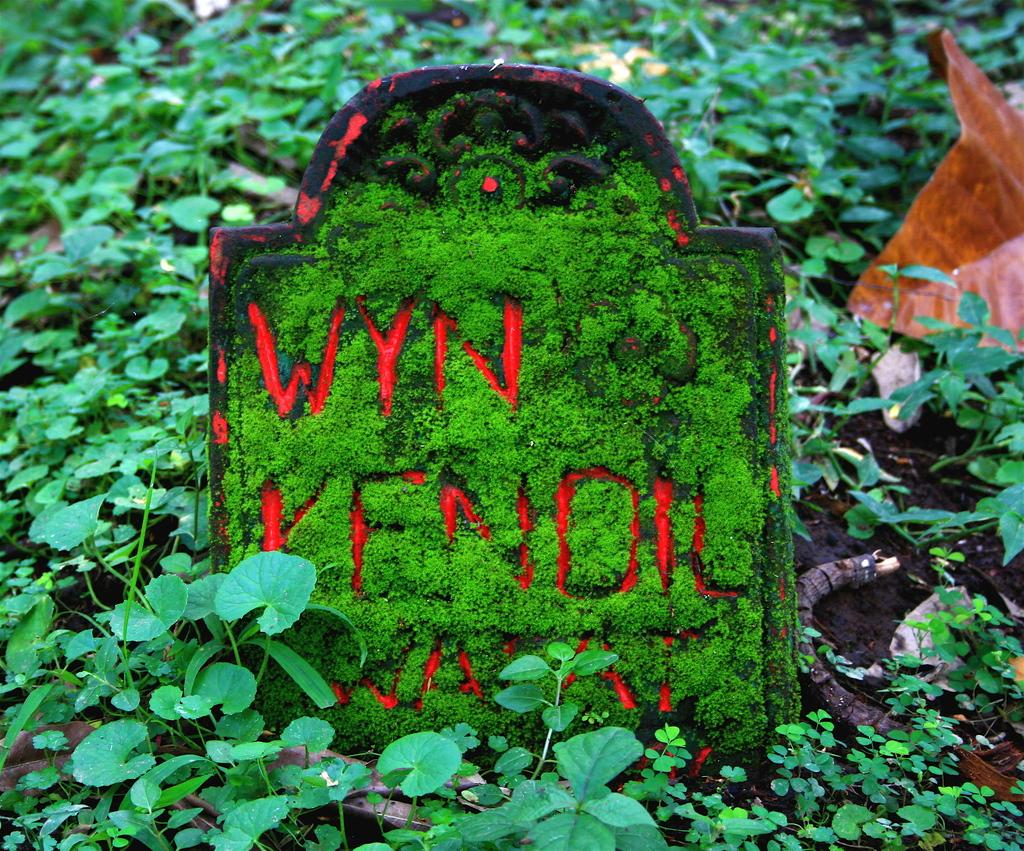What type of surface is visible in the image? There is ground visible in the image. What is present on the ground? There are plants and objects on the ground. Can you describe the object with text in the image? Unfortunately, the facts provided do not give enough information to describe the object with text. How does the grass in the image increase in size? There is no grass present in the image, so it cannot increase in size. 